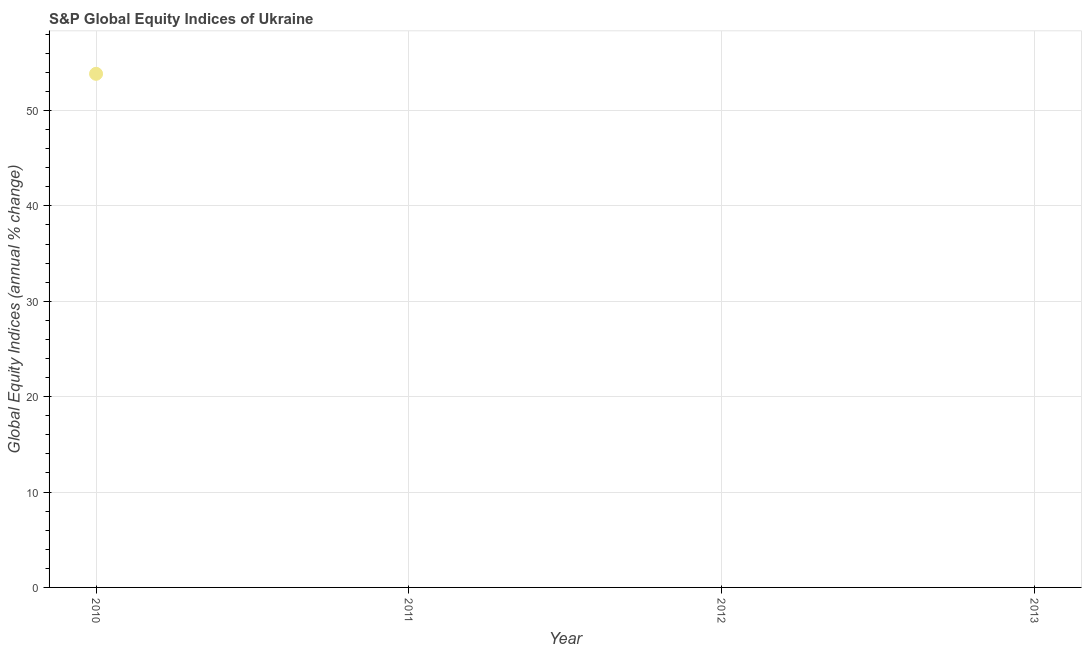Across all years, what is the maximum s&p global equity indices?
Provide a short and direct response. 53.84. Across all years, what is the minimum s&p global equity indices?
Make the answer very short. 0. What is the sum of the s&p global equity indices?
Give a very brief answer. 53.84. What is the average s&p global equity indices per year?
Make the answer very short. 13.46. What is the difference between the highest and the lowest s&p global equity indices?
Ensure brevity in your answer.  53.84. How many dotlines are there?
Make the answer very short. 1. How many years are there in the graph?
Ensure brevity in your answer.  4. Does the graph contain grids?
Give a very brief answer. Yes. What is the title of the graph?
Offer a terse response. S&P Global Equity Indices of Ukraine. What is the label or title of the Y-axis?
Provide a short and direct response. Global Equity Indices (annual % change). What is the Global Equity Indices (annual % change) in 2010?
Keep it short and to the point. 53.84. What is the Global Equity Indices (annual % change) in 2013?
Provide a short and direct response. 0. 